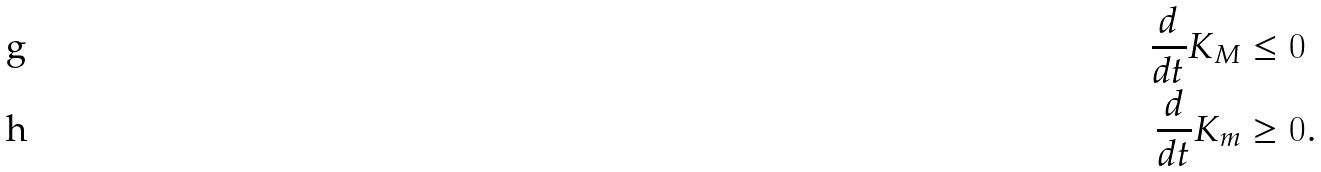Convert formula to latex. <formula><loc_0><loc_0><loc_500><loc_500>\frac { d } { d t } K _ { M } & \leq 0 \\ \frac { d } { d t } K _ { m } & \geq 0 .</formula> 